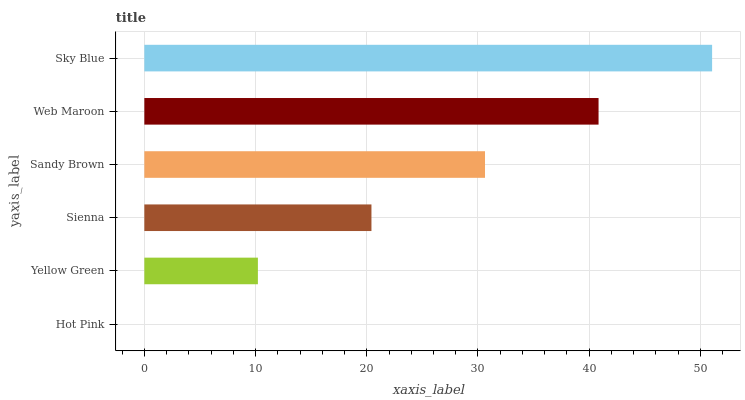Is Hot Pink the minimum?
Answer yes or no. Yes. Is Sky Blue the maximum?
Answer yes or no. Yes. Is Yellow Green the minimum?
Answer yes or no. No. Is Yellow Green the maximum?
Answer yes or no. No. Is Yellow Green greater than Hot Pink?
Answer yes or no. Yes. Is Hot Pink less than Yellow Green?
Answer yes or no. Yes. Is Hot Pink greater than Yellow Green?
Answer yes or no. No. Is Yellow Green less than Hot Pink?
Answer yes or no. No. Is Sandy Brown the high median?
Answer yes or no. Yes. Is Sienna the low median?
Answer yes or no. Yes. Is Yellow Green the high median?
Answer yes or no. No. Is Yellow Green the low median?
Answer yes or no. No. 